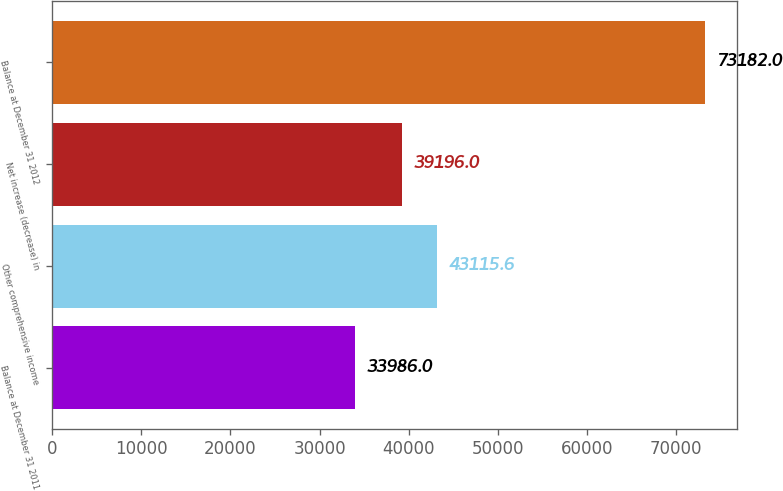<chart> <loc_0><loc_0><loc_500><loc_500><bar_chart><fcel>Balance at December 31 2011<fcel>Other comprehensive income<fcel>Net increase (decrease) in<fcel>Balance at December 31 2012<nl><fcel>33986<fcel>43115.6<fcel>39196<fcel>73182<nl></chart> 